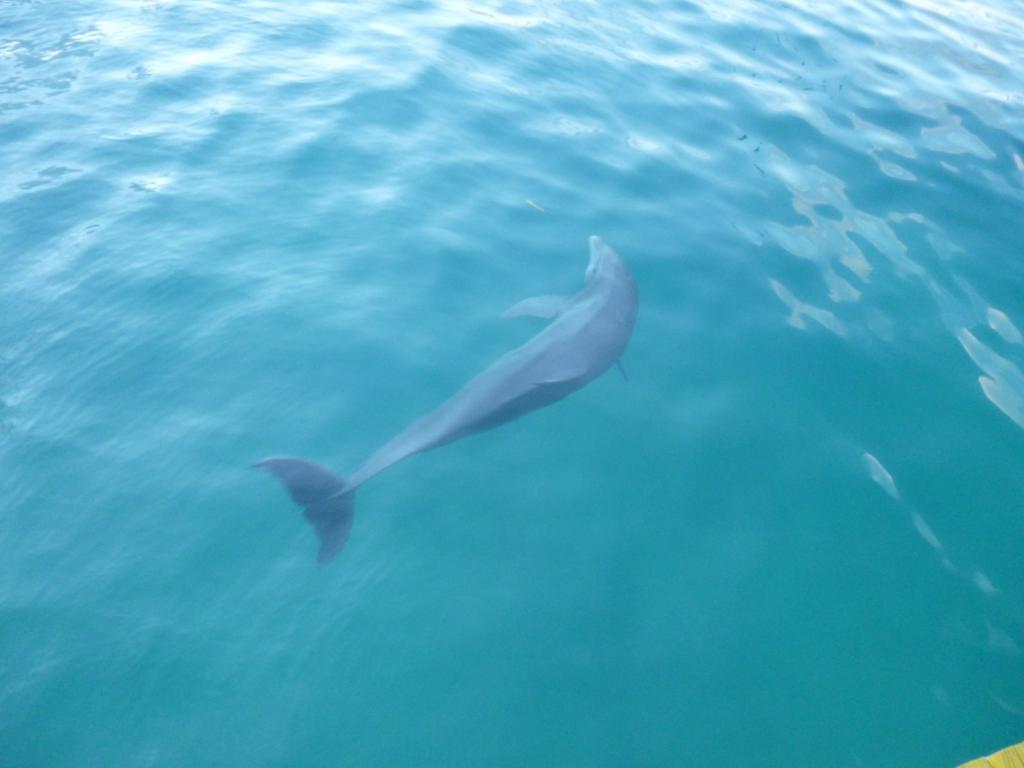Where was the image taken? The image was taken in the sea. What can be seen in the water in the middle of the image? There is a dolphin in the water in the middle of the image. What type of light is being used to illuminate the dolphin in the image? There is no specific light source mentioned or visible in the image, as it appears to be taken in natural daylight. 